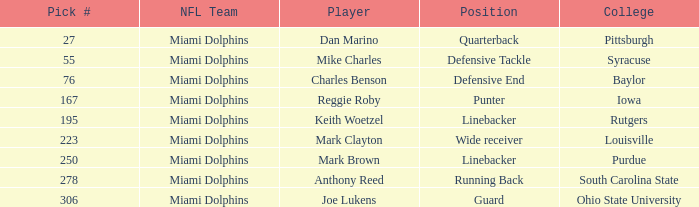Which player in the defensive end position has a pick number under 223? Charles Benson. 